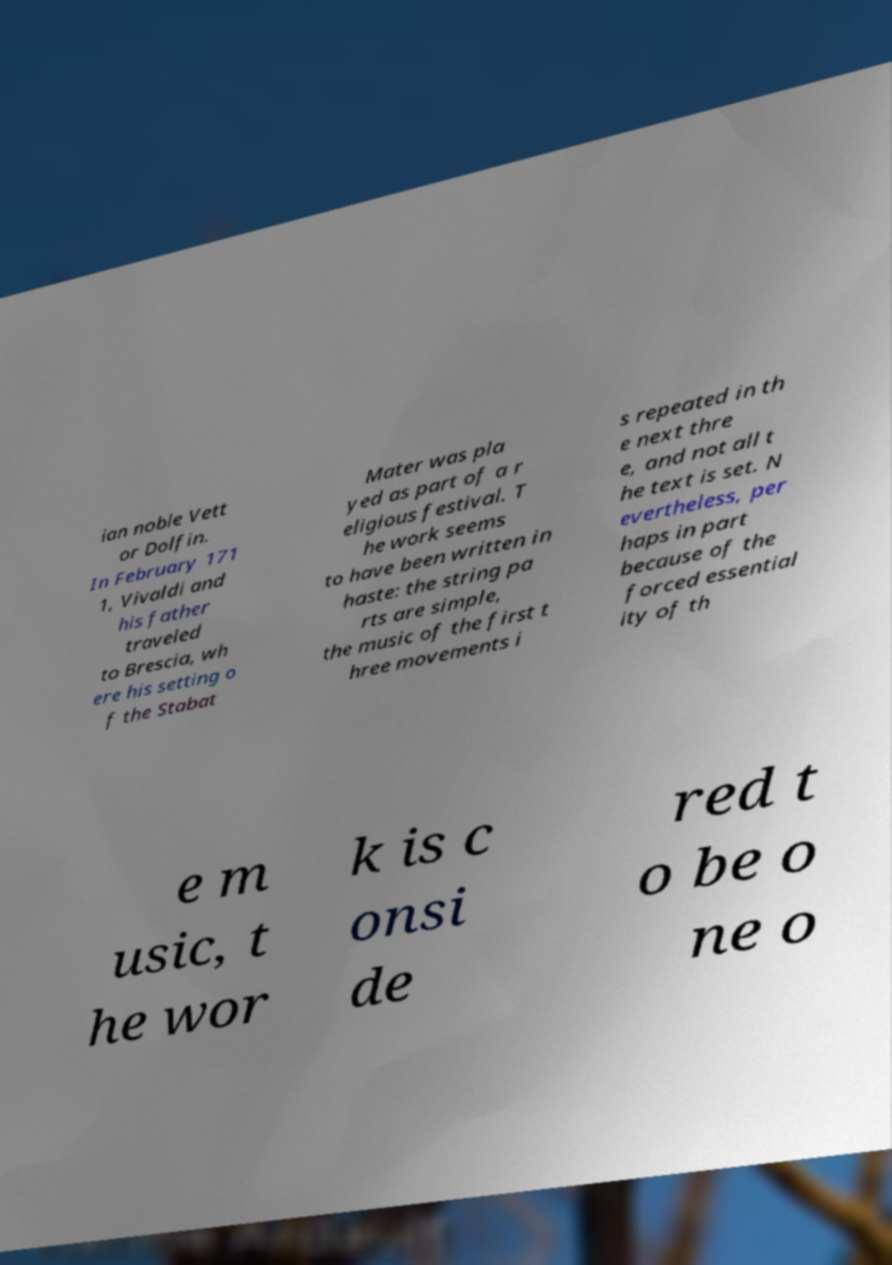Could you assist in decoding the text presented in this image and type it out clearly? ian noble Vett or Dolfin. In February 171 1, Vivaldi and his father traveled to Brescia, wh ere his setting o f the Stabat Mater was pla yed as part of a r eligious festival. T he work seems to have been written in haste: the string pa rts are simple, the music of the first t hree movements i s repeated in th e next thre e, and not all t he text is set. N evertheless, per haps in part because of the forced essential ity of th e m usic, t he wor k is c onsi de red t o be o ne o 